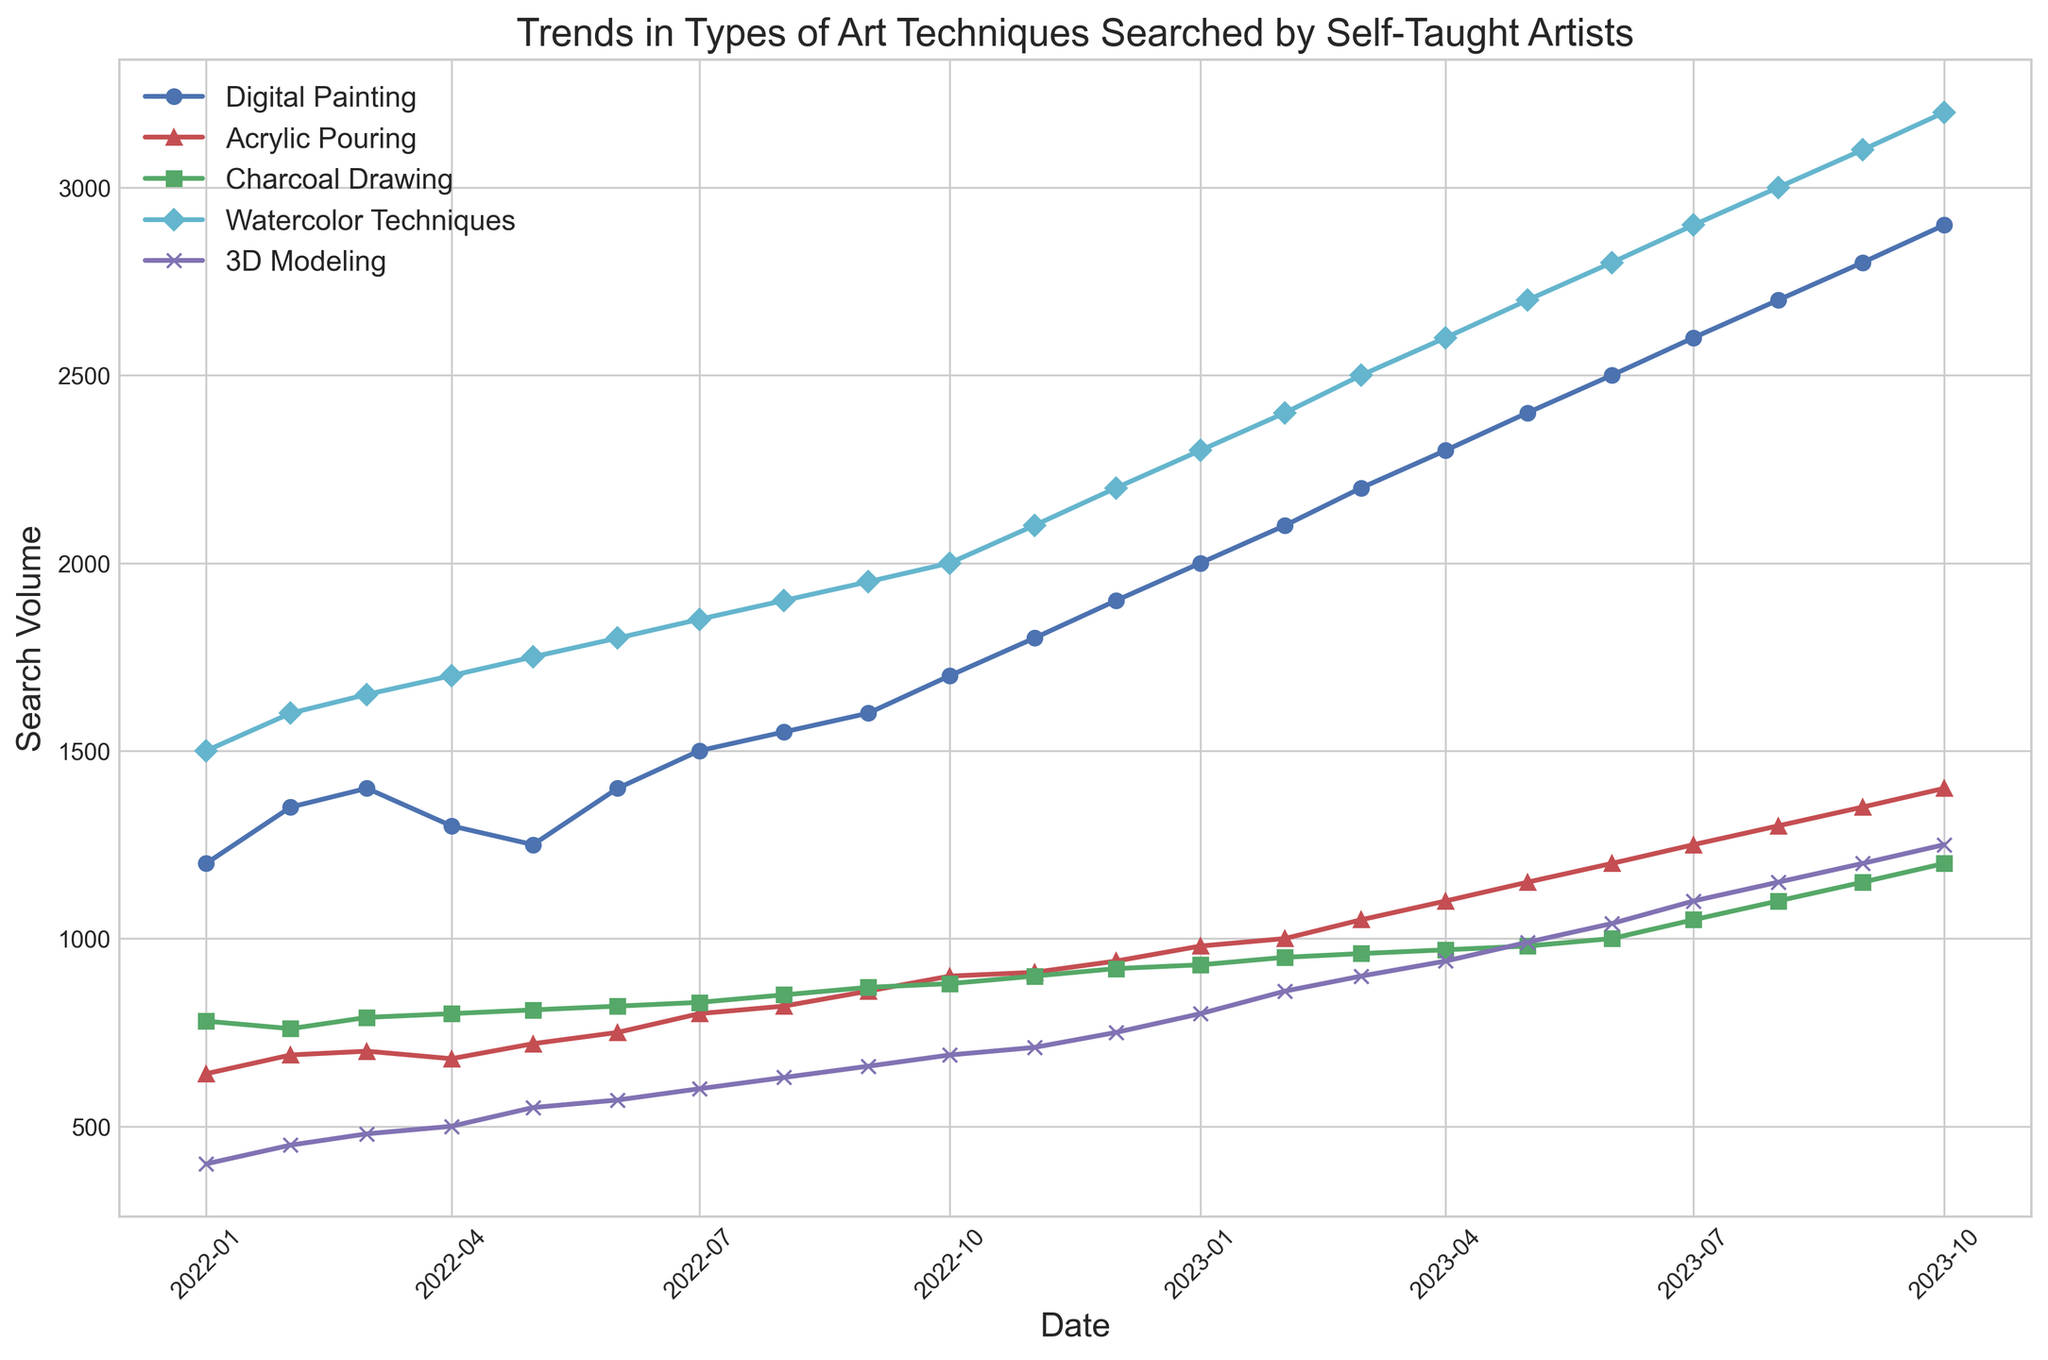What is the trend for the search volume of "Digital Painting" from January 2022 to October 2023? To discern the trend, one should observe the line representing "Digital Painting." It starts at around 1200 in January 2022 and rises continuously, reaching around 2900 by October 2023. This indicates a clear upward trend.
Answer: An upward trend Which technique showed the most significant increase in search volume from January 2022 to October 2023? By observing the plots, "Digital Painting" started at 1200 and rose to 2900, indicating an increase of 1700. Comparing this with other techniques, it's the most substantial increase.
Answer: Digital Painting How does the search volume of "3D Modeling" in October 2023 compare to "Watercolor Techniques" in the same month? In October 2023, the search volume for "Watercolor Techniques" reaches 3200, and "3D Modeling" reaches 1250. "Watercolor Techniques" thus has a much higher search volume.
Answer: Higher What is the average search volume for "Acrylic Pouring" over the first six months of 2022? Sum the values from January to June for "Acrylic Pouring" (640, 690, 700, 680, 720, 750) and divide by 6. (640+690+700+680+720+750)/6 = 697.
Answer: 697 Which art technique had the least variation in search volume over the period from January 2022 to October 2023? To determine this, examine the range of each line's fluctuation. "Charcoal Drawing" has relatively stable search values, moving from 780 to 1200. In contrast, other techniques show more significant variability.
Answer: Charcoal Drawing In which month did "Watercolor Techniques" surpass 2500 searches? Locate the point where the search volume for "Watercolor Techniques" exceeds 2500. This occurs in March 2023.
Answer: March 2023 By how much did the search volume for "Digital Painting" increase between January 2023 and April 2023? In January 2023, the search volume for "Digital Painting" was 2000. In April 2023, it was 2300. The increase is 2300 - 2000 = 300.
Answer: 300 What is the cumulative increase in search volume for "3D Modeling" from January 2022 to October 2023? Subtract the starting search volume for "3D Modeling" in January 2022 (400) from the search volume in October 2023 (1250). The increase is 1250 - 400 = 850.
Answer: 850 Which month shows a sudden spike in search volume for "Acrylic Pouring"? Look for a significant jump in the "Acrylic Pouring" trend. A notable spike happens between June 2023, with 750, and July 2023, with 800.
Answer: July 2023 